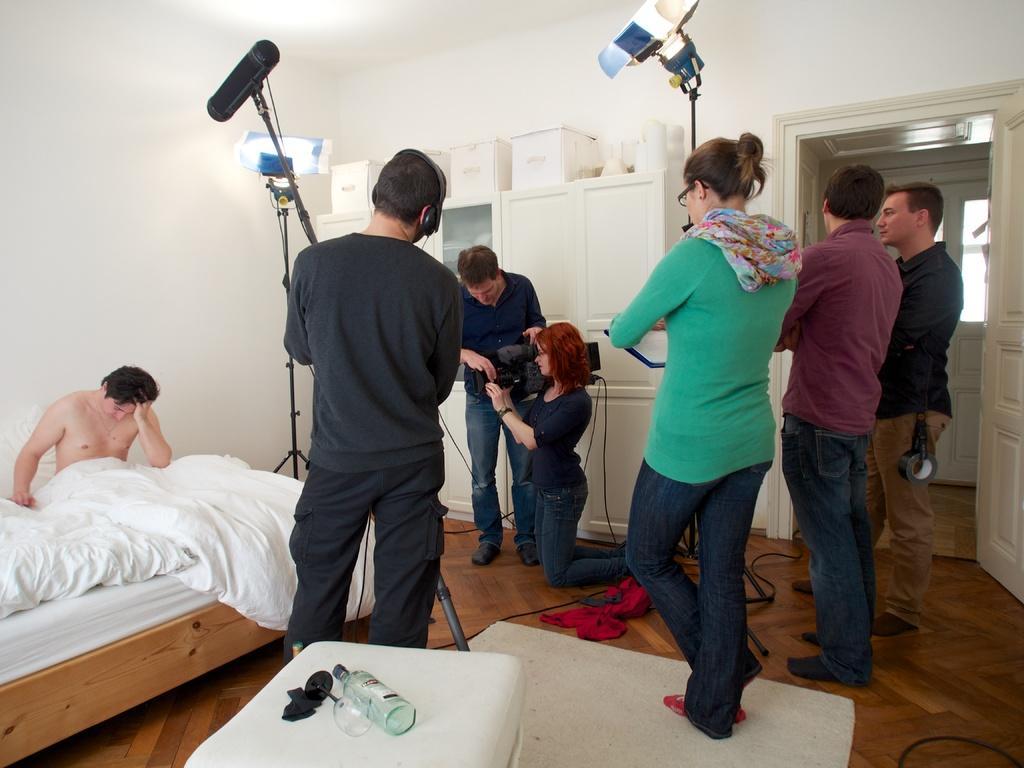Describe this image in one or two sentences. In this picture on the right side, we can see 3 people standing on the wooden floor in a white room with a door. In the center we can see people holding video cameras, headsets, Flash lights with stands. On the left side, we can see a person sitting on a white bed and there is also a chair with a bottle and a glass on it. In the background, we can see a white cupboard. 